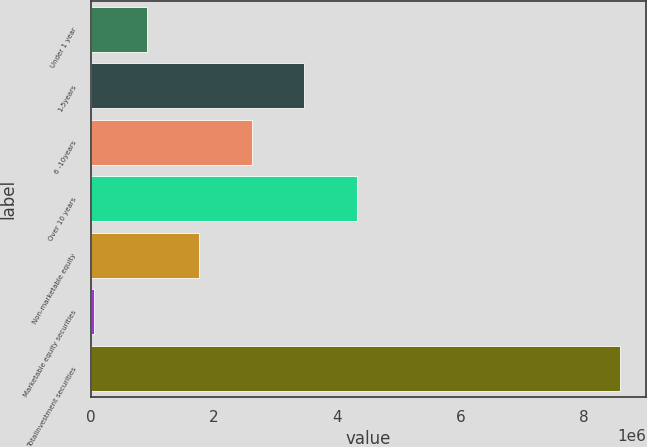Convert chart. <chart><loc_0><loc_0><loc_500><loc_500><bar_chart><fcel>Under 1 year<fcel>1-5years<fcel>6 -10years<fcel>Over 10 years<fcel>Non-marketable equity<fcel>Marketable equity securities<fcel>Totalinvestment securities<nl><fcel>907380<fcel>3.46756e+06<fcel>2.61417e+06<fcel>4.32095e+06<fcel>1.76077e+06<fcel>53987<fcel>8.58791e+06<nl></chart> 